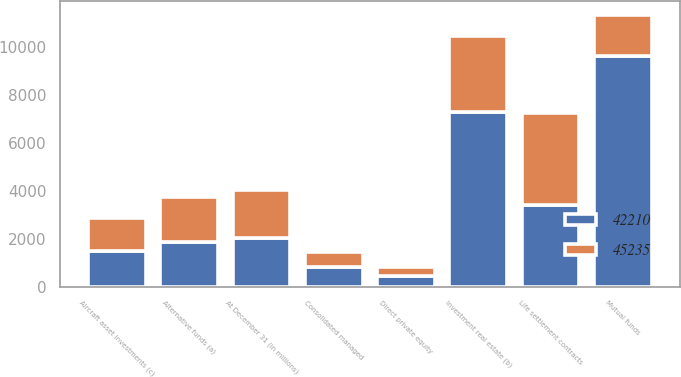<chart> <loc_0><loc_0><loc_500><loc_500><stacked_bar_chart><ecel><fcel>At December 31 (in millions)<fcel>Alternative funds (a)<fcel>Mutual funds<fcel>Investment real estate (b)<fcel>Aircraft asset investments (c)<fcel>Life settlement contracts<fcel>Consolidated managed<fcel>Direct private equity<nl><fcel>45235<fcel>2010<fcel>1863.5<fcel>1718<fcel>3196<fcel>1381<fcel>3834<fcel>638<fcel>383<nl><fcel>42210<fcel>2009<fcel>1863.5<fcel>9623<fcel>7262<fcel>1498<fcel>3399<fcel>816<fcel>443<nl></chart> 